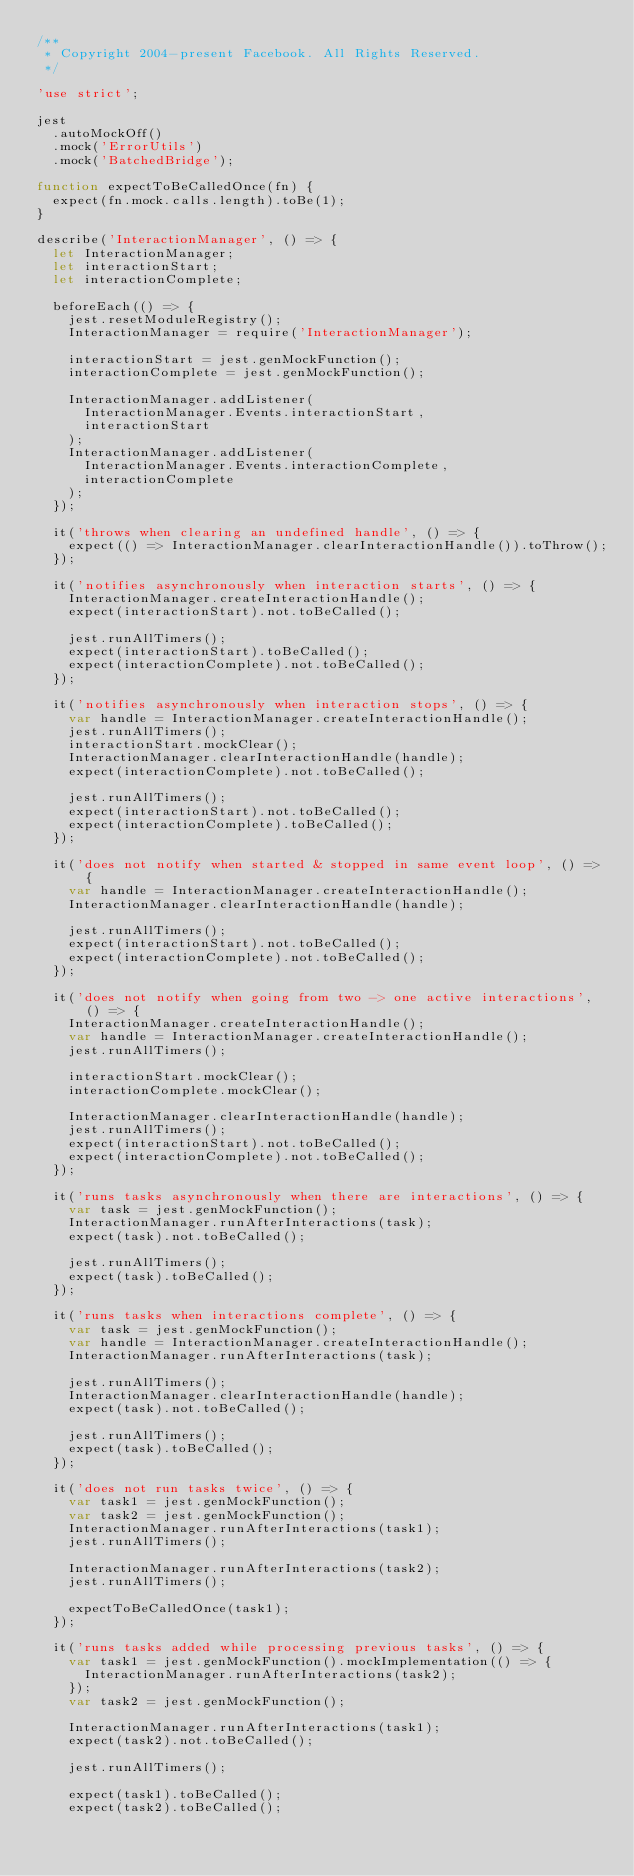Convert code to text. <code><loc_0><loc_0><loc_500><loc_500><_JavaScript_>/**
 * Copyright 2004-present Facebook. All Rights Reserved.
 */

'use strict';

jest
  .autoMockOff()
  .mock('ErrorUtils')
  .mock('BatchedBridge');

function expectToBeCalledOnce(fn) {
  expect(fn.mock.calls.length).toBe(1);
}

describe('InteractionManager', () => {
  let InteractionManager;
  let interactionStart;
  let interactionComplete;

  beforeEach(() => {
    jest.resetModuleRegistry();
    InteractionManager = require('InteractionManager');

    interactionStart = jest.genMockFunction();
    interactionComplete = jest.genMockFunction();

    InteractionManager.addListener(
      InteractionManager.Events.interactionStart,
      interactionStart
    );
    InteractionManager.addListener(
      InteractionManager.Events.interactionComplete,
      interactionComplete
    );
  });

  it('throws when clearing an undefined handle', () => {
    expect(() => InteractionManager.clearInteractionHandle()).toThrow();
  });

  it('notifies asynchronously when interaction starts', () => {
    InteractionManager.createInteractionHandle();
    expect(interactionStart).not.toBeCalled();

    jest.runAllTimers();
    expect(interactionStart).toBeCalled();
    expect(interactionComplete).not.toBeCalled();
  });

  it('notifies asynchronously when interaction stops', () => {
    var handle = InteractionManager.createInteractionHandle();
    jest.runAllTimers();
    interactionStart.mockClear();
    InteractionManager.clearInteractionHandle(handle);
    expect(interactionComplete).not.toBeCalled();

    jest.runAllTimers();
    expect(interactionStart).not.toBeCalled();
    expect(interactionComplete).toBeCalled();
  });

  it('does not notify when started & stopped in same event loop', () => {
    var handle = InteractionManager.createInteractionHandle();
    InteractionManager.clearInteractionHandle(handle);

    jest.runAllTimers();
    expect(interactionStart).not.toBeCalled();
    expect(interactionComplete).not.toBeCalled();
  });

  it('does not notify when going from two -> one active interactions', () => {
    InteractionManager.createInteractionHandle();
    var handle = InteractionManager.createInteractionHandle();
    jest.runAllTimers();

    interactionStart.mockClear();
    interactionComplete.mockClear();

    InteractionManager.clearInteractionHandle(handle);
    jest.runAllTimers();
    expect(interactionStart).not.toBeCalled();
    expect(interactionComplete).not.toBeCalled();
  });

  it('runs tasks asynchronously when there are interactions', () => {
    var task = jest.genMockFunction();
    InteractionManager.runAfterInteractions(task);
    expect(task).not.toBeCalled();

    jest.runAllTimers();
    expect(task).toBeCalled();
  });

  it('runs tasks when interactions complete', () => {
    var task = jest.genMockFunction();
    var handle = InteractionManager.createInteractionHandle();
    InteractionManager.runAfterInteractions(task);

    jest.runAllTimers();
    InteractionManager.clearInteractionHandle(handle);
    expect(task).not.toBeCalled();

    jest.runAllTimers();
    expect(task).toBeCalled();
  });

  it('does not run tasks twice', () => {
    var task1 = jest.genMockFunction();
    var task2 = jest.genMockFunction();
    InteractionManager.runAfterInteractions(task1);
    jest.runAllTimers();

    InteractionManager.runAfterInteractions(task2);
    jest.runAllTimers();

    expectToBeCalledOnce(task1);
  });

  it('runs tasks added while processing previous tasks', () => {
    var task1 = jest.genMockFunction().mockImplementation(() => {
      InteractionManager.runAfterInteractions(task2);
    });
    var task2 = jest.genMockFunction();

    InteractionManager.runAfterInteractions(task1);
    expect(task2).not.toBeCalled();

    jest.runAllTimers();

    expect(task1).toBeCalled();
    expect(task2).toBeCalled();</code> 